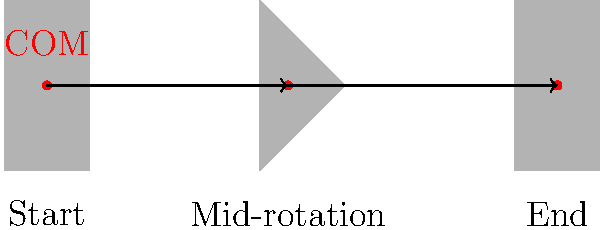Analice el movimiento del centro de masa (COM) durante un salto mortal de un gimnasta. ¿Qué trayectoria sigue el COM durante la rotación completa, y cómo se relaciona esto con los principios de conservación del momento angular? Para analizar el movimiento del centro de masa (COM) durante un salto mortal, sigamos estos pasos:

1. Observación inicial: En la gráfica, vemos tres siluetas que representan las posiciones clave del gimnasta durante un salto mortal.

2. Trayectoria del COM:
   a) El punto rojo en cada silueta representa el COM.
   b) Notamos que el COM sigue una trayectoria aproximadamente lineal y horizontal.

3. Principio de conservación del momento angular:
   a) El momento angular se define como $L = I\omega$, donde $I$ es el momento de inercia y $\omega$ es la velocidad angular.
   b) En ausencia de fuerzas externas (exceptuando la gravedad), el momento angular total se conserva.

4. Relación con el movimiento del COM:
   a) Al iniciar el salto, el gimnasta genera un momento angular inicial.
   b) Durante la rotación, el gimnasta cambia su forma (de extendido a agrupado y de nuevo a extendido), lo que altera su momento de inercia.
   c) Para conservar el momento angular, la velocidad angular cambia inversamente al cambio en el momento de inercia: $I_1\omega_1 = I_2\omega_2$

5. Trayectoria parabólica:
   a) Aunque el COM parece seguir una línea recta en la simplificación 2D, en realidad sigue una trayectoria parabólica debido a la gravedad.
   b) La ecuación de movimiento para el COM en el eje vertical sería: $y = y_0 + v_0t - \frac{1}{2}gt^2$

6. Importancia para el rendimiento:
   a) Mantener el COM en una trayectoria estable permite al gimnasta maximizar el control y la precisión del movimiento.
   b) La manipulación del momento de inercia (agrupándose y extendiéndose) permite al gimnasta controlar la velocidad de rotación sin cambiar el momento angular total.
Answer: El COM sigue una trayectoria parabólica, manteniendo el momento angular constante mientras el gimnasta altera su momento de inercia para controlar la rotación. 